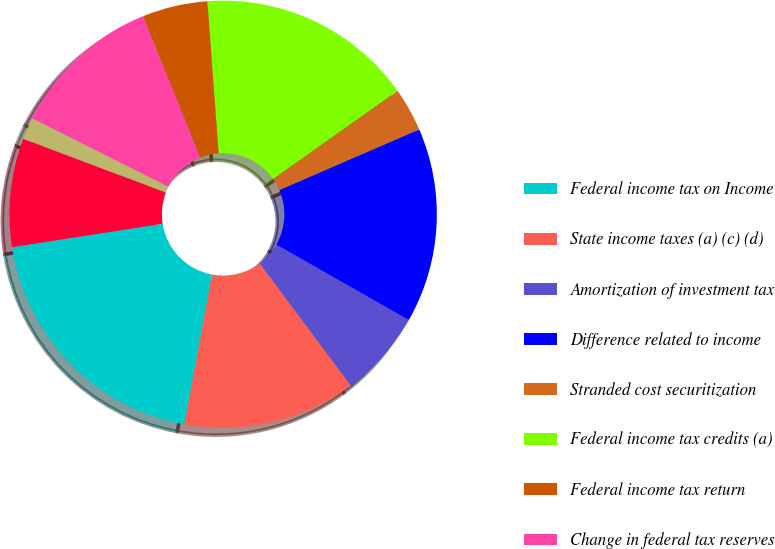<chart> <loc_0><loc_0><loc_500><loc_500><pie_chart><fcel>Federal income tax on Income<fcel>State income taxes (a) (c) (d)<fcel>Amortization of investment tax<fcel>Difference related to income<fcel>Stranded cost securitization<fcel>Federal income tax credits (a)<fcel>Federal income tax return<fcel>Change in federal tax reserves<fcel>Foreign income tax return<fcel>Domestic manufacturing<nl><fcel>19.64%<fcel>13.1%<fcel>6.57%<fcel>14.74%<fcel>3.3%<fcel>16.37%<fcel>4.94%<fcel>11.47%<fcel>1.67%<fcel>8.2%<nl></chart> 